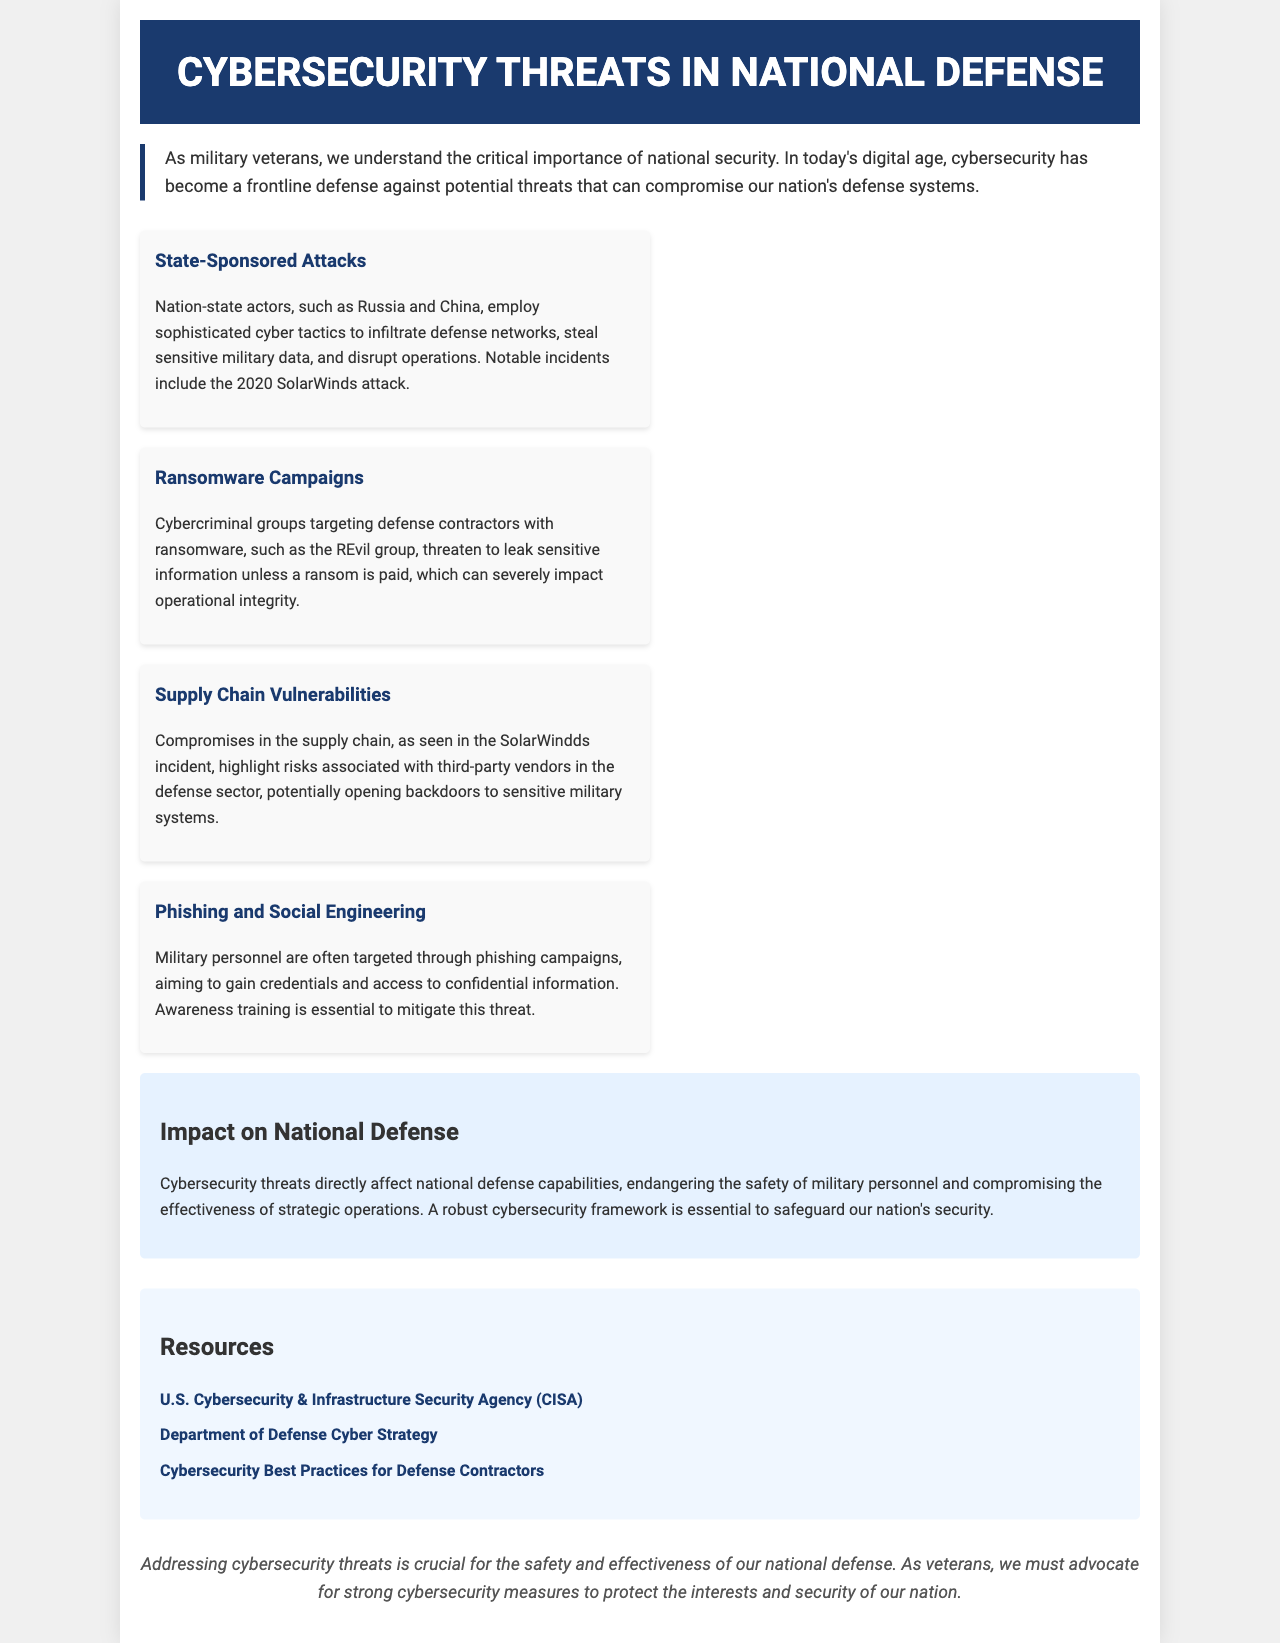What is the title of the document? The title of the document is found in the header section, which indicates the main topic of the brochure.
Answer: Cybersecurity Threats in National Defense Who are the state-sponsored attack actors mentioned? The document details specific nation-states that are known for engaging in cyber-attacks against national defense systems.
Answer: Russia and China What incident is noted in the context of supply chain vulnerabilities? The document refers to a specific incident to illustrate the risks associated with defense supply chains.
Answer: SolarWinds incident What is the essential measure mentioned to mitigate phishing threats? The text outlines a preventive strategy focusing on education and awareness to reduce the risks from phishing attacks.
Answer: Awareness training What type of attacks target defense contractors with ransomware? The document describes a specific category of cybercrime aimed at defense-related organizations to extort sensitive information.
Answer: Ransomware campaigns What color is used for the header background? The style section of the document specifies the color associated with the header, which is crucial for branding the brochure.
Answer: Dark blue What is the impact of cybersecurity threats as mentioned in the document? The document summarizes the consequences of these threats, particularly concerning military safety and operations.
Answer: Compromising the effectiveness of strategic operations How many threats are listed in the brochure? The list of cybersecurity threats is clearly enumerated in the respective section of the document.
Answer: Four What organization is linked to cybersecurity resources? The brochure provides a specific link for guidance and practices related to cybersecurity for national defense.
Answer: U.S. Cybersecurity & Infrastructure Security Agency (CISA) 